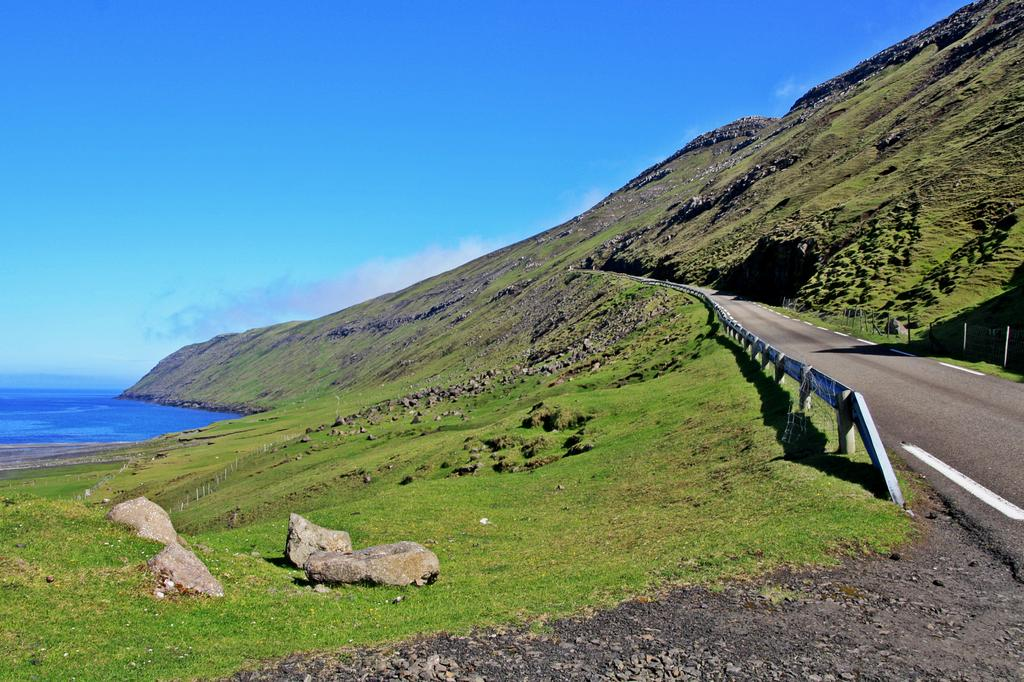What is the main feature of the image? There is a road in the image. What can be seen on the right side of the road? There is small fencing on the right side of the road. What geographical feature is present in the image? There is a hill in the image. What type of terrain is visible in the image? There are rocks and grass in the image. What is on the left side of the road? There is water on the left side of the image. What can be seen in the background of the image? The sky is visible in the background of the image. What type of snow can be seen on the hill in the image? There is no snow present in the image; it features a hill with rocks and grass. What type of wilderness animals can be seen in the image? There are no wilderness animals visible in the image. 